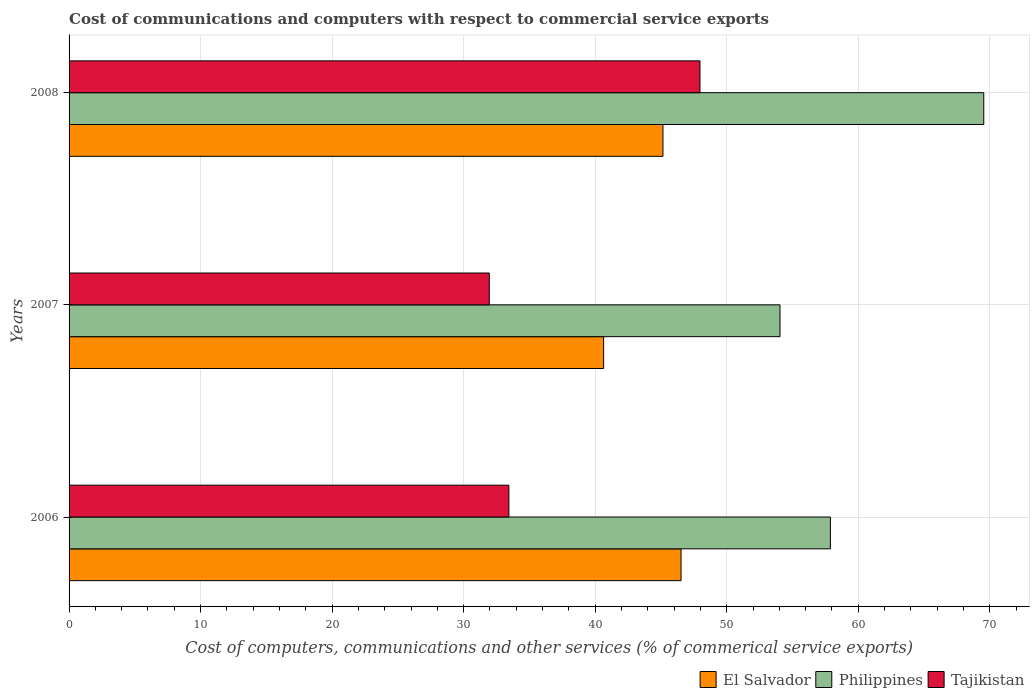Are the number of bars on each tick of the Y-axis equal?
Give a very brief answer. Yes. What is the label of the 3rd group of bars from the top?
Provide a succinct answer. 2006. What is the cost of communications and computers in Philippines in 2006?
Your response must be concise. 57.88. Across all years, what is the maximum cost of communications and computers in Tajikistan?
Offer a very short reply. 47.96. Across all years, what is the minimum cost of communications and computers in Philippines?
Offer a very short reply. 54.05. In which year was the cost of communications and computers in Tajikistan maximum?
Offer a terse response. 2008. In which year was the cost of communications and computers in Tajikistan minimum?
Provide a short and direct response. 2007. What is the total cost of communications and computers in Tajikistan in the graph?
Your answer should be compact. 113.35. What is the difference between the cost of communications and computers in Philippines in 2006 and that in 2008?
Offer a very short reply. -11.66. What is the difference between the cost of communications and computers in Tajikistan in 2008 and the cost of communications and computers in Philippines in 2007?
Keep it short and to the point. -6.09. What is the average cost of communications and computers in El Salvador per year?
Offer a terse response. 44.11. In the year 2008, what is the difference between the cost of communications and computers in El Salvador and cost of communications and computers in Philippines?
Provide a short and direct response. -24.39. In how many years, is the cost of communications and computers in Philippines greater than 18 %?
Provide a succinct answer. 3. What is the ratio of the cost of communications and computers in Tajikistan in 2006 to that in 2007?
Make the answer very short. 1.05. Is the cost of communications and computers in El Salvador in 2007 less than that in 2008?
Ensure brevity in your answer.  Yes. Is the difference between the cost of communications and computers in El Salvador in 2006 and 2007 greater than the difference between the cost of communications and computers in Philippines in 2006 and 2007?
Your answer should be compact. Yes. What is the difference between the highest and the second highest cost of communications and computers in El Salvador?
Your response must be concise. 1.38. What is the difference between the highest and the lowest cost of communications and computers in El Salvador?
Offer a terse response. 5.89. What does the 2nd bar from the top in 2006 represents?
Offer a terse response. Philippines. What does the 1st bar from the bottom in 2006 represents?
Your answer should be compact. El Salvador. Is it the case that in every year, the sum of the cost of communications and computers in Philippines and cost of communications and computers in El Salvador is greater than the cost of communications and computers in Tajikistan?
Keep it short and to the point. Yes. How many bars are there?
Keep it short and to the point. 9. What is the difference between two consecutive major ticks on the X-axis?
Keep it short and to the point. 10. Are the values on the major ticks of X-axis written in scientific E-notation?
Your response must be concise. No. Does the graph contain any zero values?
Offer a very short reply. No. Does the graph contain grids?
Offer a terse response. Yes. Where does the legend appear in the graph?
Make the answer very short. Bottom right. How many legend labels are there?
Your answer should be very brief. 3. What is the title of the graph?
Offer a terse response. Cost of communications and computers with respect to commercial service exports. Does "American Samoa" appear as one of the legend labels in the graph?
Your answer should be compact. No. What is the label or title of the X-axis?
Give a very brief answer. Cost of computers, communications and other services (% of commerical service exports). What is the label or title of the Y-axis?
Ensure brevity in your answer.  Years. What is the Cost of computers, communications and other services (% of commerical service exports) of El Salvador in 2006?
Offer a terse response. 46.53. What is the Cost of computers, communications and other services (% of commerical service exports) in Philippines in 2006?
Keep it short and to the point. 57.88. What is the Cost of computers, communications and other services (% of commerical service exports) in Tajikistan in 2006?
Offer a terse response. 33.44. What is the Cost of computers, communications and other services (% of commerical service exports) of El Salvador in 2007?
Keep it short and to the point. 40.64. What is the Cost of computers, communications and other services (% of commerical service exports) of Philippines in 2007?
Provide a succinct answer. 54.05. What is the Cost of computers, communications and other services (% of commerical service exports) in Tajikistan in 2007?
Offer a very short reply. 31.95. What is the Cost of computers, communications and other services (% of commerical service exports) in El Salvador in 2008?
Make the answer very short. 45.15. What is the Cost of computers, communications and other services (% of commerical service exports) in Philippines in 2008?
Give a very brief answer. 69.54. What is the Cost of computers, communications and other services (% of commerical service exports) of Tajikistan in 2008?
Your answer should be compact. 47.96. Across all years, what is the maximum Cost of computers, communications and other services (% of commerical service exports) in El Salvador?
Keep it short and to the point. 46.53. Across all years, what is the maximum Cost of computers, communications and other services (% of commerical service exports) of Philippines?
Your answer should be very brief. 69.54. Across all years, what is the maximum Cost of computers, communications and other services (% of commerical service exports) of Tajikistan?
Provide a short and direct response. 47.96. Across all years, what is the minimum Cost of computers, communications and other services (% of commerical service exports) in El Salvador?
Keep it short and to the point. 40.64. Across all years, what is the minimum Cost of computers, communications and other services (% of commerical service exports) of Philippines?
Provide a short and direct response. 54.05. Across all years, what is the minimum Cost of computers, communications and other services (% of commerical service exports) in Tajikistan?
Offer a terse response. 31.95. What is the total Cost of computers, communications and other services (% of commerical service exports) of El Salvador in the graph?
Provide a short and direct response. 132.32. What is the total Cost of computers, communications and other services (% of commerical service exports) of Philippines in the graph?
Ensure brevity in your answer.  181.47. What is the total Cost of computers, communications and other services (% of commerical service exports) of Tajikistan in the graph?
Make the answer very short. 113.35. What is the difference between the Cost of computers, communications and other services (% of commerical service exports) in El Salvador in 2006 and that in 2007?
Give a very brief answer. 5.89. What is the difference between the Cost of computers, communications and other services (% of commerical service exports) of Philippines in 2006 and that in 2007?
Your response must be concise. 3.83. What is the difference between the Cost of computers, communications and other services (% of commerical service exports) in Tajikistan in 2006 and that in 2007?
Keep it short and to the point. 1.49. What is the difference between the Cost of computers, communications and other services (% of commerical service exports) in El Salvador in 2006 and that in 2008?
Keep it short and to the point. 1.38. What is the difference between the Cost of computers, communications and other services (% of commerical service exports) of Philippines in 2006 and that in 2008?
Make the answer very short. -11.66. What is the difference between the Cost of computers, communications and other services (% of commerical service exports) in Tajikistan in 2006 and that in 2008?
Provide a short and direct response. -14.53. What is the difference between the Cost of computers, communications and other services (% of commerical service exports) of El Salvador in 2007 and that in 2008?
Provide a short and direct response. -4.51. What is the difference between the Cost of computers, communications and other services (% of commerical service exports) of Philippines in 2007 and that in 2008?
Make the answer very short. -15.49. What is the difference between the Cost of computers, communications and other services (% of commerical service exports) in Tajikistan in 2007 and that in 2008?
Your answer should be very brief. -16.02. What is the difference between the Cost of computers, communications and other services (% of commerical service exports) in El Salvador in 2006 and the Cost of computers, communications and other services (% of commerical service exports) in Philippines in 2007?
Give a very brief answer. -7.52. What is the difference between the Cost of computers, communications and other services (% of commerical service exports) in El Salvador in 2006 and the Cost of computers, communications and other services (% of commerical service exports) in Tajikistan in 2007?
Keep it short and to the point. 14.58. What is the difference between the Cost of computers, communications and other services (% of commerical service exports) of Philippines in 2006 and the Cost of computers, communications and other services (% of commerical service exports) of Tajikistan in 2007?
Make the answer very short. 25.93. What is the difference between the Cost of computers, communications and other services (% of commerical service exports) in El Salvador in 2006 and the Cost of computers, communications and other services (% of commerical service exports) in Philippines in 2008?
Ensure brevity in your answer.  -23.01. What is the difference between the Cost of computers, communications and other services (% of commerical service exports) in El Salvador in 2006 and the Cost of computers, communications and other services (% of commerical service exports) in Tajikistan in 2008?
Offer a very short reply. -1.44. What is the difference between the Cost of computers, communications and other services (% of commerical service exports) in Philippines in 2006 and the Cost of computers, communications and other services (% of commerical service exports) in Tajikistan in 2008?
Your response must be concise. 9.92. What is the difference between the Cost of computers, communications and other services (% of commerical service exports) in El Salvador in 2007 and the Cost of computers, communications and other services (% of commerical service exports) in Philippines in 2008?
Make the answer very short. -28.9. What is the difference between the Cost of computers, communications and other services (% of commerical service exports) in El Salvador in 2007 and the Cost of computers, communications and other services (% of commerical service exports) in Tajikistan in 2008?
Give a very brief answer. -7.32. What is the difference between the Cost of computers, communications and other services (% of commerical service exports) of Philippines in 2007 and the Cost of computers, communications and other services (% of commerical service exports) of Tajikistan in 2008?
Offer a terse response. 6.09. What is the average Cost of computers, communications and other services (% of commerical service exports) in El Salvador per year?
Make the answer very short. 44.11. What is the average Cost of computers, communications and other services (% of commerical service exports) of Philippines per year?
Make the answer very short. 60.49. What is the average Cost of computers, communications and other services (% of commerical service exports) of Tajikistan per year?
Offer a terse response. 37.78. In the year 2006, what is the difference between the Cost of computers, communications and other services (% of commerical service exports) in El Salvador and Cost of computers, communications and other services (% of commerical service exports) in Philippines?
Offer a terse response. -11.35. In the year 2006, what is the difference between the Cost of computers, communications and other services (% of commerical service exports) of El Salvador and Cost of computers, communications and other services (% of commerical service exports) of Tajikistan?
Provide a succinct answer. 13.09. In the year 2006, what is the difference between the Cost of computers, communications and other services (% of commerical service exports) of Philippines and Cost of computers, communications and other services (% of commerical service exports) of Tajikistan?
Your answer should be compact. 24.44. In the year 2007, what is the difference between the Cost of computers, communications and other services (% of commerical service exports) in El Salvador and Cost of computers, communications and other services (% of commerical service exports) in Philippines?
Keep it short and to the point. -13.41. In the year 2007, what is the difference between the Cost of computers, communications and other services (% of commerical service exports) of El Salvador and Cost of computers, communications and other services (% of commerical service exports) of Tajikistan?
Provide a succinct answer. 8.69. In the year 2007, what is the difference between the Cost of computers, communications and other services (% of commerical service exports) in Philippines and Cost of computers, communications and other services (% of commerical service exports) in Tajikistan?
Offer a terse response. 22.1. In the year 2008, what is the difference between the Cost of computers, communications and other services (% of commerical service exports) of El Salvador and Cost of computers, communications and other services (% of commerical service exports) of Philippines?
Make the answer very short. -24.39. In the year 2008, what is the difference between the Cost of computers, communications and other services (% of commerical service exports) of El Salvador and Cost of computers, communications and other services (% of commerical service exports) of Tajikistan?
Provide a succinct answer. -2.81. In the year 2008, what is the difference between the Cost of computers, communications and other services (% of commerical service exports) of Philippines and Cost of computers, communications and other services (% of commerical service exports) of Tajikistan?
Your answer should be very brief. 21.58. What is the ratio of the Cost of computers, communications and other services (% of commerical service exports) of El Salvador in 2006 to that in 2007?
Give a very brief answer. 1.14. What is the ratio of the Cost of computers, communications and other services (% of commerical service exports) in Philippines in 2006 to that in 2007?
Provide a short and direct response. 1.07. What is the ratio of the Cost of computers, communications and other services (% of commerical service exports) in Tajikistan in 2006 to that in 2007?
Your answer should be compact. 1.05. What is the ratio of the Cost of computers, communications and other services (% of commerical service exports) in El Salvador in 2006 to that in 2008?
Your response must be concise. 1.03. What is the ratio of the Cost of computers, communications and other services (% of commerical service exports) of Philippines in 2006 to that in 2008?
Provide a succinct answer. 0.83. What is the ratio of the Cost of computers, communications and other services (% of commerical service exports) of Tajikistan in 2006 to that in 2008?
Offer a very short reply. 0.7. What is the ratio of the Cost of computers, communications and other services (% of commerical service exports) in El Salvador in 2007 to that in 2008?
Offer a very short reply. 0.9. What is the ratio of the Cost of computers, communications and other services (% of commerical service exports) in Philippines in 2007 to that in 2008?
Your answer should be compact. 0.78. What is the ratio of the Cost of computers, communications and other services (% of commerical service exports) of Tajikistan in 2007 to that in 2008?
Your response must be concise. 0.67. What is the difference between the highest and the second highest Cost of computers, communications and other services (% of commerical service exports) of El Salvador?
Your answer should be compact. 1.38. What is the difference between the highest and the second highest Cost of computers, communications and other services (% of commerical service exports) of Philippines?
Ensure brevity in your answer.  11.66. What is the difference between the highest and the second highest Cost of computers, communications and other services (% of commerical service exports) in Tajikistan?
Your answer should be compact. 14.53. What is the difference between the highest and the lowest Cost of computers, communications and other services (% of commerical service exports) of El Salvador?
Provide a short and direct response. 5.89. What is the difference between the highest and the lowest Cost of computers, communications and other services (% of commerical service exports) in Philippines?
Offer a terse response. 15.49. What is the difference between the highest and the lowest Cost of computers, communications and other services (% of commerical service exports) of Tajikistan?
Your answer should be compact. 16.02. 